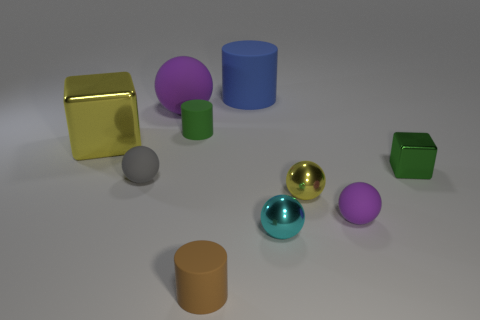Subtract all small cylinders. How many cylinders are left? 1 Subtract all gray spheres. How many spheres are left? 4 Subtract 2 cubes. How many cubes are left? 0 Subtract all blocks. How many objects are left? 8 Subtract all purple blocks. How many yellow balls are left? 1 Add 1 tiny cyan metallic balls. How many tiny cyan metallic balls exist? 2 Subtract 1 yellow cubes. How many objects are left? 9 Subtract all red cylinders. Subtract all cyan blocks. How many cylinders are left? 3 Subtract all small yellow matte things. Subtract all big rubber balls. How many objects are left? 9 Add 9 cyan balls. How many cyan balls are left? 10 